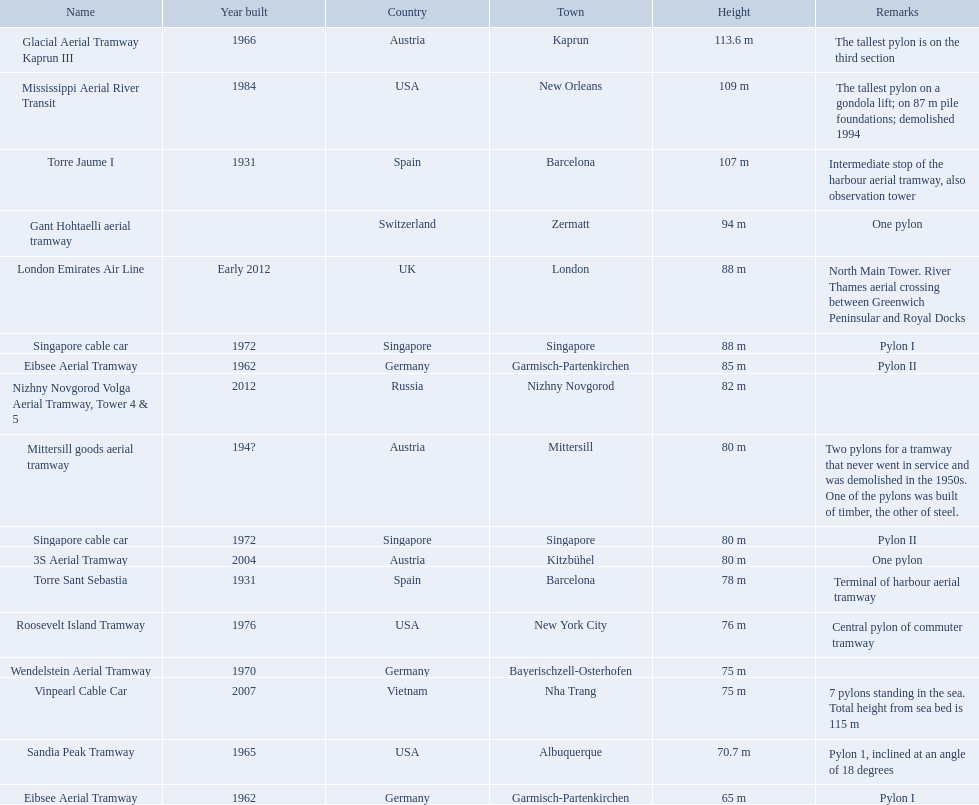Which lift has the second highest height? Mississippi Aerial River Transit. What is the value of the height? 109 m. Which lift achieves the second highest elevation? Mississippi Aerial River Transit. What is the amount of the height? 109 m. 